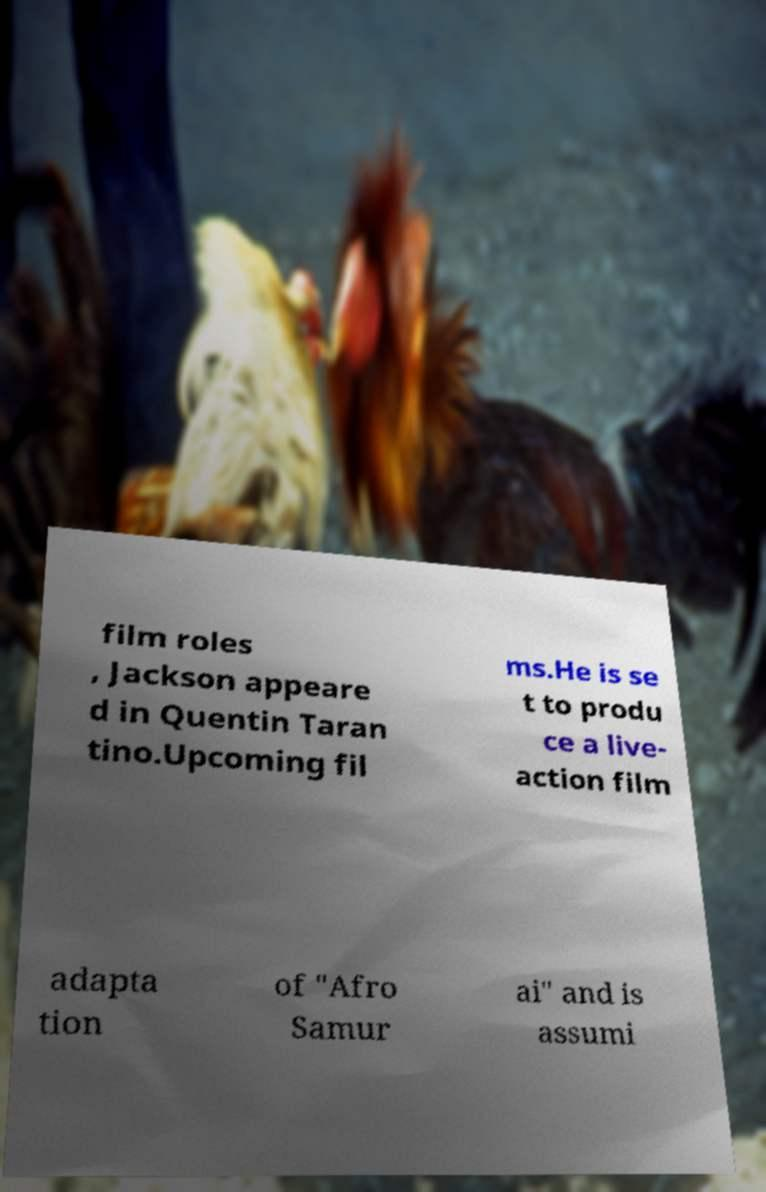For documentation purposes, I need the text within this image transcribed. Could you provide that? film roles , Jackson appeare d in Quentin Taran tino.Upcoming fil ms.He is se t to produ ce a live- action film adapta tion of "Afro Samur ai" and is assumi 